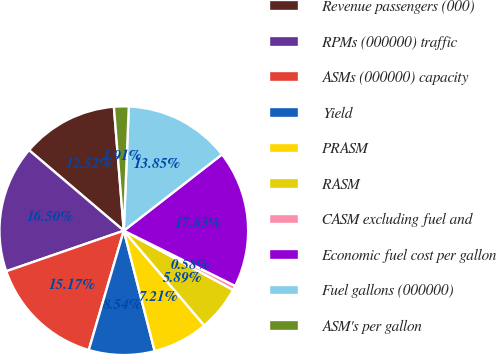Convert chart. <chart><loc_0><loc_0><loc_500><loc_500><pie_chart><fcel>Revenue passengers (000)<fcel>RPMs (000000) traffic<fcel>ASMs (000000) capacity<fcel>Yield<fcel>PRASM<fcel>RASM<fcel>CASM excluding fuel and<fcel>Economic fuel cost per gallon<fcel>Fuel gallons (000000)<fcel>ASM's per gallon<nl><fcel>12.52%<fcel>16.5%<fcel>15.17%<fcel>8.54%<fcel>7.21%<fcel>5.89%<fcel>0.58%<fcel>17.83%<fcel>13.85%<fcel>1.91%<nl></chart> 